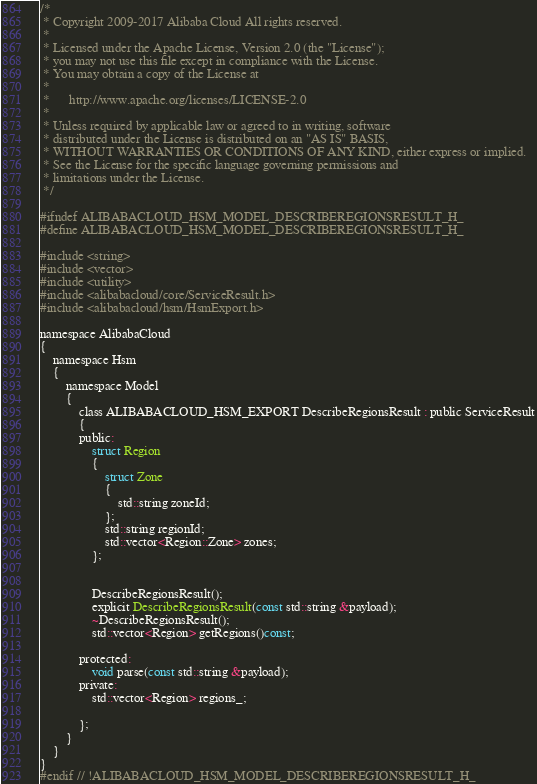Convert code to text. <code><loc_0><loc_0><loc_500><loc_500><_C_>/*
 * Copyright 2009-2017 Alibaba Cloud All rights reserved.
 * 
 * Licensed under the Apache License, Version 2.0 (the "License");
 * you may not use this file except in compliance with the License.
 * You may obtain a copy of the License at
 * 
 *      http://www.apache.org/licenses/LICENSE-2.0
 * 
 * Unless required by applicable law or agreed to in writing, software
 * distributed under the License is distributed on an "AS IS" BASIS,
 * WITHOUT WARRANTIES OR CONDITIONS OF ANY KIND, either express or implied.
 * See the License for the specific language governing permissions and
 * limitations under the License.
 */

#ifndef ALIBABACLOUD_HSM_MODEL_DESCRIBEREGIONSRESULT_H_
#define ALIBABACLOUD_HSM_MODEL_DESCRIBEREGIONSRESULT_H_

#include <string>
#include <vector>
#include <utility>
#include <alibabacloud/core/ServiceResult.h>
#include <alibabacloud/hsm/HsmExport.h>

namespace AlibabaCloud
{
	namespace Hsm
	{
		namespace Model
		{
			class ALIBABACLOUD_HSM_EXPORT DescribeRegionsResult : public ServiceResult
			{
			public:
				struct Region
				{
					struct Zone
					{
						std::string zoneId;
					};
					std::string regionId;
					std::vector<Region::Zone> zones;
				};


				DescribeRegionsResult();
				explicit DescribeRegionsResult(const std::string &payload);
				~DescribeRegionsResult();
				std::vector<Region> getRegions()const;

			protected:
				void parse(const std::string &payload);
			private:
				std::vector<Region> regions_;

			};
		}
	}
}
#endif // !ALIBABACLOUD_HSM_MODEL_DESCRIBEREGIONSRESULT_H_</code> 